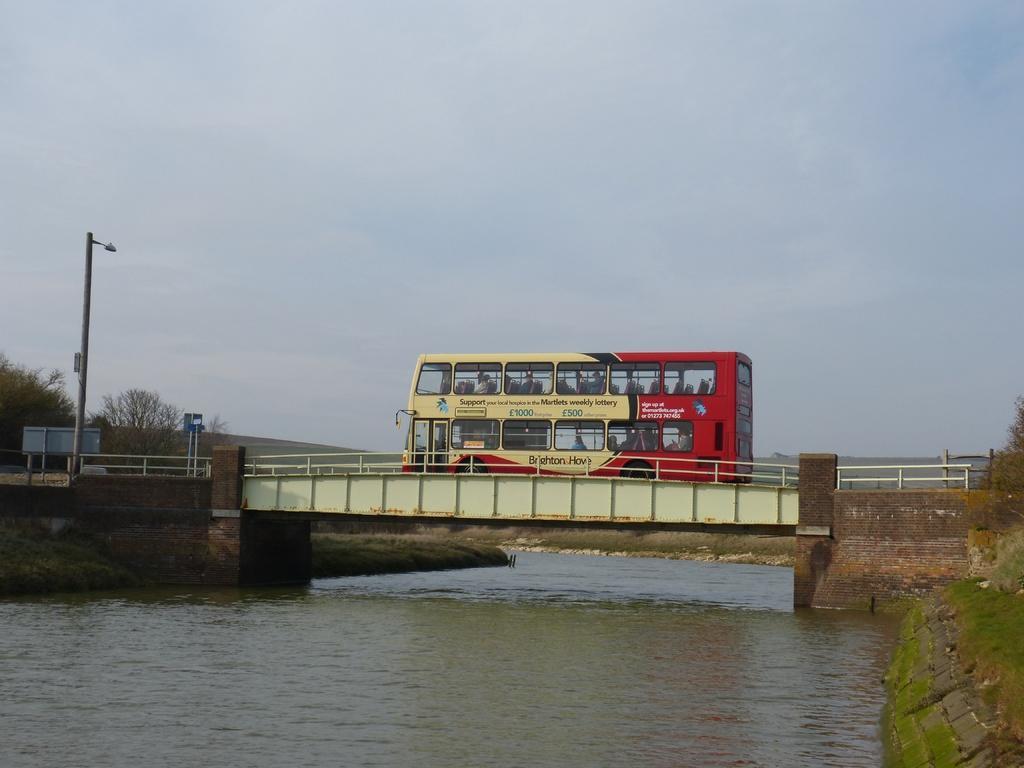Can you describe this image briefly? In this image I see the bridge over here and I see a bus on it which is of cream and red in color and I see a light pole over here and I see the water under the bridge and in the background I see the sky and I can also see the trees. 